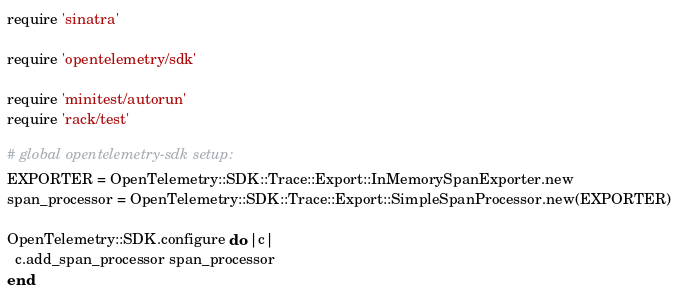Convert code to text. <code><loc_0><loc_0><loc_500><loc_500><_Ruby_>
require 'sinatra'

require 'opentelemetry/sdk'

require 'minitest/autorun'
require 'rack/test'

# global opentelemetry-sdk setup:
EXPORTER = OpenTelemetry::SDK::Trace::Export::InMemorySpanExporter.new
span_processor = OpenTelemetry::SDK::Trace::Export::SimpleSpanProcessor.new(EXPORTER)

OpenTelemetry::SDK.configure do |c|
  c.add_span_processor span_processor
end
</code> 